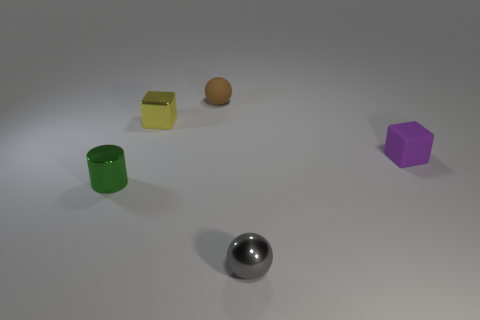Add 3 blue cylinders. How many objects exist? 8 Subtract all cubes. How many objects are left? 3 Add 5 small metallic things. How many small metallic things are left? 8 Add 4 red matte cylinders. How many red matte cylinders exist? 4 Subtract 0 yellow cylinders. How many objects are left? 5 Subtract all rubber blocks. Subtract all gray spheres. How many objects are left? 3 